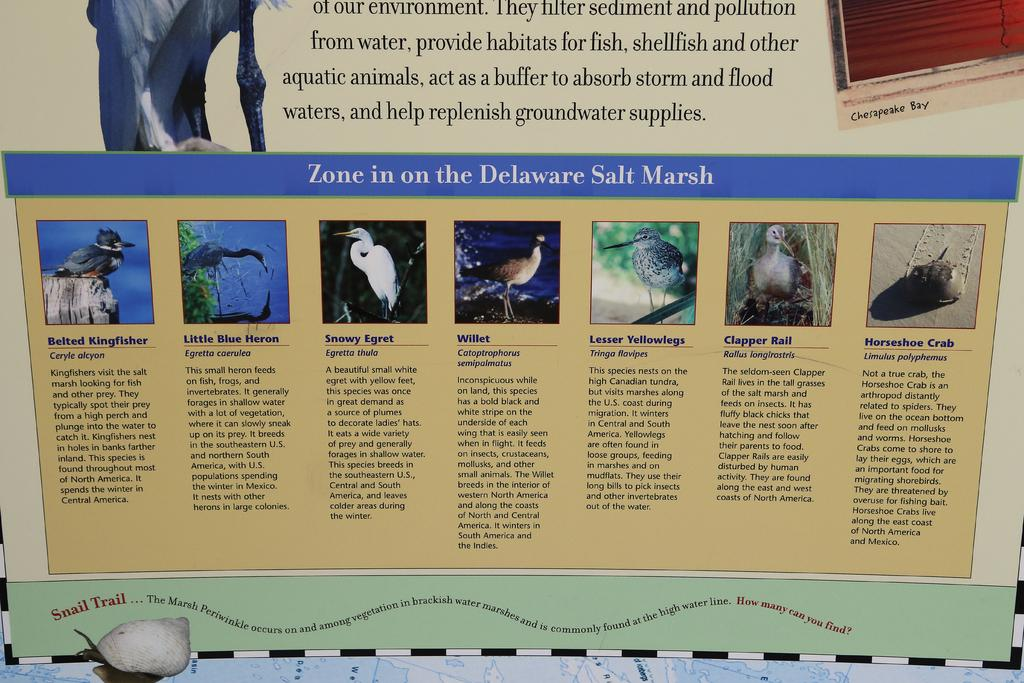What is the main object in the image? There is a board in the image. What type of locket is hanging from the board in the image? There is no locket present in the image; it only features a board. How many dolls are sitting on the board in the image? There are no dolls present in the image; it only features a board. 